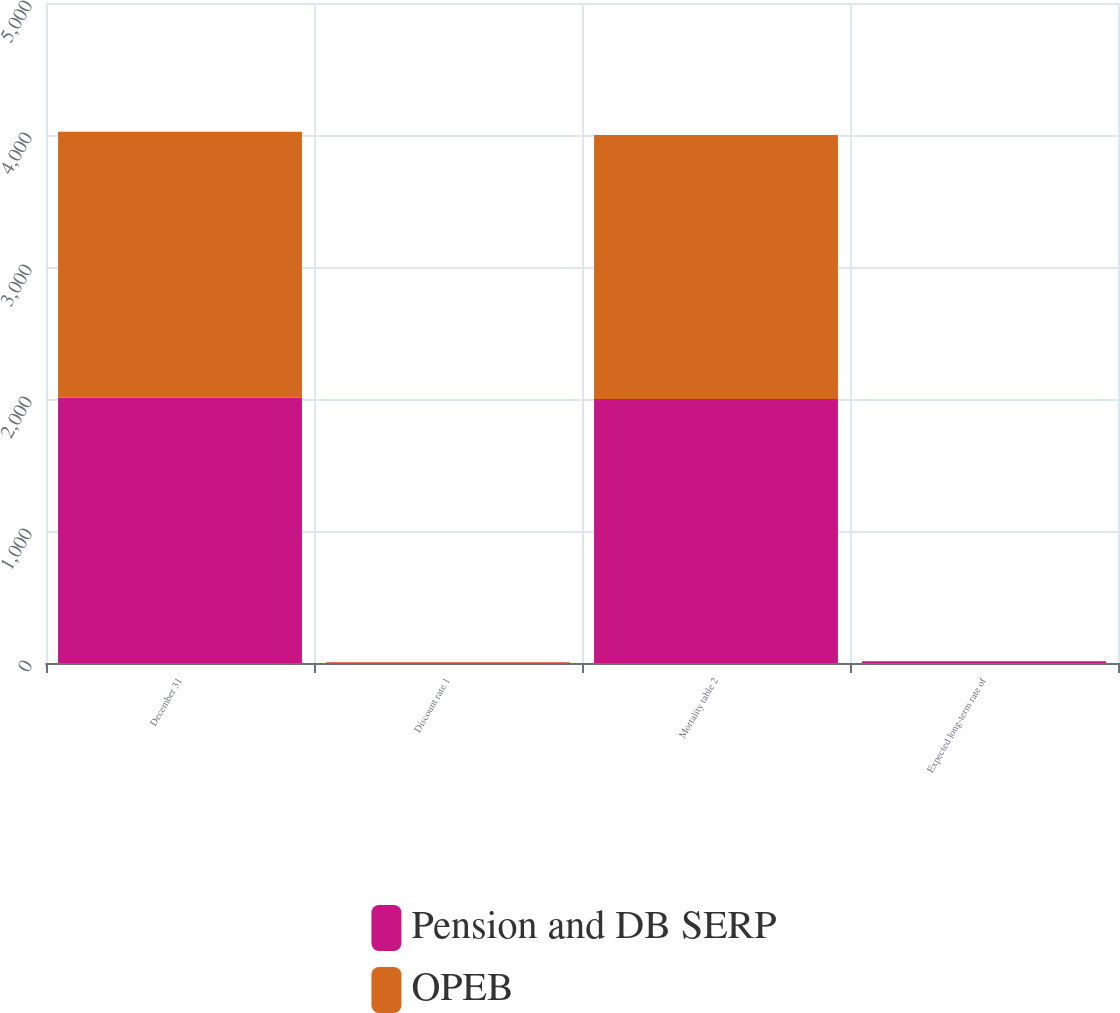Convert chart to OTSL. <chart><loc_0><loc_0><loc_500><loc_500><stacked_bar_chart><ecel><fcel>December 31<fcel>Discount rate 1<fcel>Mortality table 2<fcel>Expected long-term rate of<nl><fcel>Pension and DB SERP<fcel>2012<fcel>4.1<fcel>2000<fcel>7.75<nl><fcel>OPEB<fcel>2012<fcel>4.4<fcel>2000<fcel>7.25<nl></chart> 